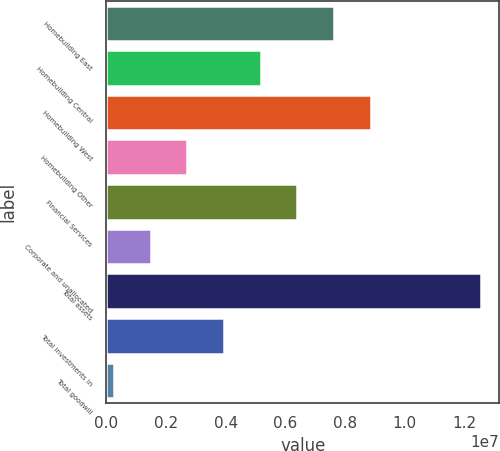<chart> <loc_0><loc_0><loc_500><loc_500><bar_chart><fcel>Homebuilding East<fcel>Homebuilding Central<fcel>Homebuilding West<fcel>Homebuilding Other<fcel>Financial Services<fcel>Corporate and unallocated<fcel>Total assets<fcel>Total investments in<fcel>Total goodwill<nl><fcel>7.62599e+06<fcel>5.16838e+06<fcel>8.8548e+06<fcel>2.71076e+06<fcel>6.39718e+06<fcel>1.48195e+06<fcel>1.25412e+07<fcel>3.93957e+06<fcel>253144<nl></chart> 